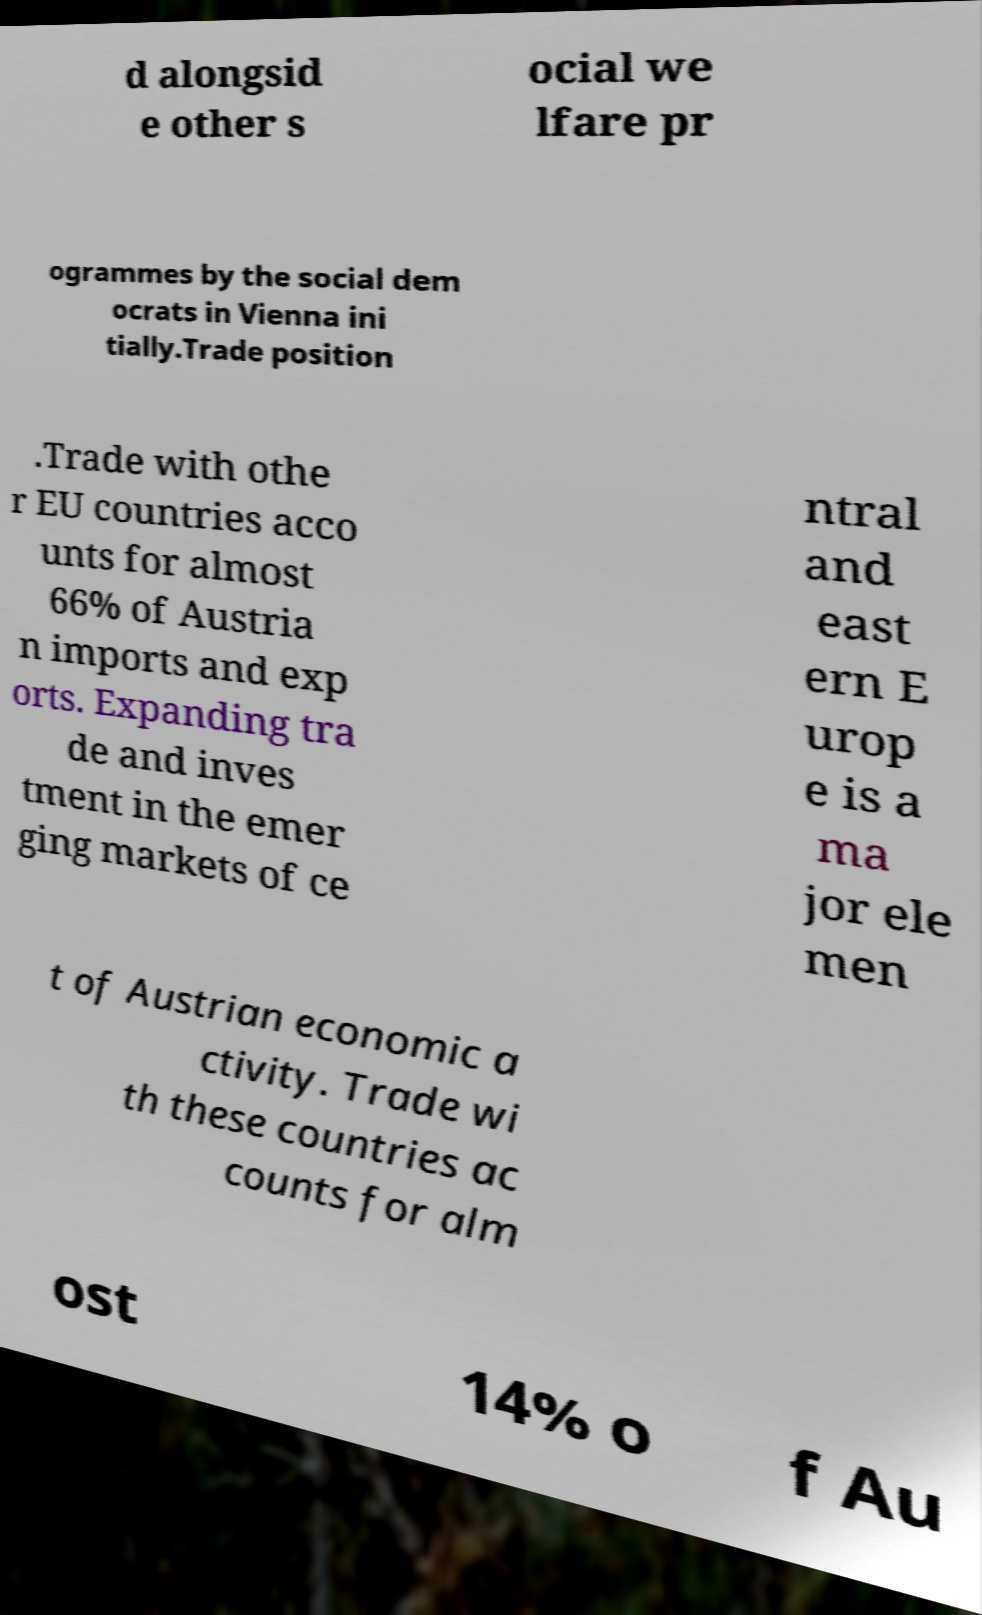What messages or text are displayed in this image? I need them in a readable, typed format. d alongsid e other s ocial we lfare pr ogrammes by the social dem ocrats in Vienna ini tially.Trade position .Trade with othe r EU countries acco unts for almost 66% of Austria n imports and exp orts. Expanding tra de and inves tment in the emer ging markets of ce ntral and east ern E urop e is a ma jor ele men t of Austrian economic a ctivity. Trade wi th these countries ac counts for alm ost 14% o f Au 